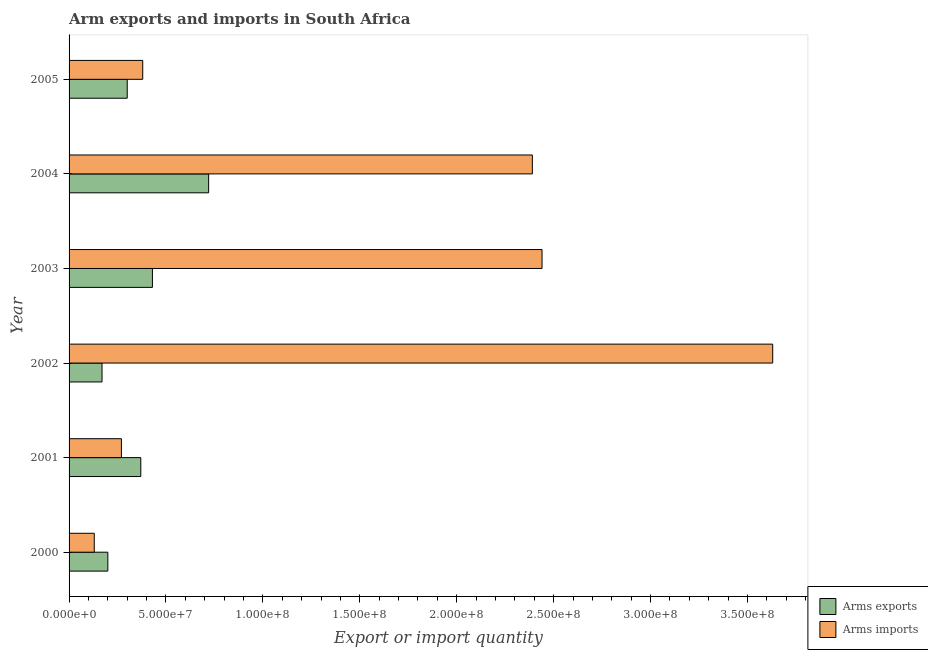How many different coloured bars are there?
Keep it short and to the point. 2. How many groups of bars are there?
Keep it short and to the point. 6. How many bars are there on the 4th tick from the top?
Provide a succinct answer. 2. How many bars are there on the 1st tick from the bottom?
Make the answer very short. 2. What is the label of the 3rd group of bars from the top?
Provide a succinct answer. 2003. In how many cases, is the number of bars for a given year not equal to the number of legend labels?
Ensure brevity in your answer.  0. What is the arms imports in 2003?
Ensure brevity in your answer.  2.44e+08. Across all years, what is the maximum arms exports?
Your answer should be very brief. 7.20e+07. Across all years, what is the minimum arms imports?
Offer a terse response. 1.30e+07. In which year was the arms imports maximum?
Your response must be concise. 2002. What is the total arms exports in the graph?
Offer a very short reply. 2.19e+08. What is the difference between the arms exports in 2001 and that in 2004?
Offer a terse response. -3.50e+07. What is the difference between the arms exports in 2002 and the arms imports in 2003?
Your response must be concise. -2.27e+08. What is the average arms exports per year?
Keep it short and to the point. 3.65e+07. In the year 2003, what is the difference between the arms exports and arms imports?
Your response must be concise. -2.01e+08. What is the ratio of the arms exports in 2000 to that in 2005?
Your answer should be very brief. 0.67. Is the arms exports in 2000 less than that in 2001?
Provide a succinct answer. Yes. What is the difference between the highest and the second highest arms imports?
Provide a succinct answer. 1.19e+08. What is the difference between the highest and the lowest arms imports?
Give a very brief answer. 3.50e+08. Is the sum of the arms exports in 2002 and 2005 greater than the maximum arms imports across all years?
Provide a short and direct response. No. What does the 2nd bar from the top in 2002 represents?
Your answer should be very brief. Arms exports. What does the 1st bar from the bottom in 2005 represents?
Your response must be concise. Arms exports. How many bars are there?
Your response must be concise. 12. Are all the bars in the graph horizontal?
Your answer should be very brief. Yes. Where does the legend appear in the graph?
Your answer should be very brief. Bottom right. What is the title of the graph?
Offer a terse response. Arm exports and imports in South Africa. Does "Fraud firms" appear as one of the legend labels in the graph?
Ensure brevity in your answer.  No. What is the label or title of the X-axis?
Offer a very short reply. Export or import quantity. What is the label or title of the Y-axis?
Your answer should be very brief. Year. What is the Export or import quantity of Arms exports in 2000?
Provide a short and direct response. 2.00e+07. What is the Export or import quantity in Arms imports in 2000?
Make the answer very short. 1.30e+07. What is the Export or import quantity of Arms exports in 2001?
Your response must be concise. 3.70e+07. What is the Export or import quantity of Arms imports in 2001?
Offer a terse response. 2.70e+07. What is the Export or import quantity of Arms exports in 2002?
Give a very brief answer. 1.70e+07. What is the Export or import quantity of Arms imports in 2002?
Provide a succinct answer. 3.63e+08. What is the Export or import quantity of Arms exports in 2003?
Make the answer very short. 4.30e+07. What is the Export or import quantity of Arms imports in 2003?
Give a very brief answer. 2.44e+08. What is the Export or import quantity in Arms exports in 2004?
Provide a short and direct response. 7.20e+07. What is the Export or import quantity in Arms imports in 2004?
Your answer should be compact. 2.39e+08. What is the Export or import quantity in Arms exports in 2005?
Your answer should be very brief. 3.00e+07. What is the Export or import quantity in Arms imports in 2005?
Provide a short and direct response. 3.80e+07. Across all years, what is the maximum Export or import quantity in Arms exports?
Your answer should be very brief. 7.20e+07. Across all years, what is the maximum Export or import quantity in Arms imports?
Your response must be concise. 3.63e+08. Across all years, what is the minimum Export or import quantity of Arms exports?
Make the answer very short. 1.70e+07. Across all years, what is the minimum Export or import quantity in Arms imports?
Your answer should be compact. 1.30e+07. What is the total Export or import quantity in Arms exports in the graph?
Ensure brevity in your answer.  2.19e+08. What is the total Export or import quantity of Arms imports in the graph?
Offer a very short reply. 9.24e+08. What is the difference between the Export or import quantity in Arms exports in 2000 and that in 2001?
Keep it short and to the point. -1.70e+07. What is the difference between the Export or import quantity of Arms imports in 2000 and that in 2001?
Your answer should be compact. -1.40e+07. What is the difference between the Export or import quantity of Arms imports in 2000 and that in 2002?
Your response must be concise. -3.50e+08. What is the difference between the Export or import quantity of Arms exports in 2000 and that in 2003?
Ensure brevity in your answer.  -2.30e+07. What is the difference between the Export or import quantity of Arms imports in 2000 and that in 2003?
Offer a terse response. -2.31e+08. What is the difference between the Export or import quantity of Arms exports in 2000 and that in 2004?
Your answer should be very brief. -5.20e+07. What is the difference between the Export or import quantity in Arms imports in 2000 and that in 2004?
Your answer should be very brief. -2.26e+08. What is the difference between the Export or import quantity of Arms exports in 2000 and that in 2005?
Provide a succinct answer. -1.00e+07. What is the difference between the Export or import quantity in Arms imports in 2000 and that in 2005?
Provide a succinct answer. -2.50e+07. What is the difference between the Export or import quantity of Arms exports in 2001 and that in 2002?
Your answer should be compact. 2.00e+07. What is the difference between the Export or import quantity in Arms imports in 2001 and that in 2002?
Ensure brevity in your answer.  -3.36e+08. What is the difference between the Export or import quantity of Arms exports in 2001 and that in 2003?
Offer a terse response. -6.00e+06. What is the difference between the Export or import quantity in Arms imports in 2001 and that in 2003?
Provide a short and direct response. -2.17e+08. What is the difference between the Export or import quantity in Arms exports in 2001 and that in 2004?
Your answer should be very brief. -3.50e+07. What is the difference between the Export or import quantity of Arms imports in 2001 and that in 2004?
Keep it short and to the point. -2.12e+08. What is the difference between the Export or import quantity of Arms imports in 2001 and that in 2005?
Your response must be concise. -1.10e+07. What is the difference between the Export or import quantity in Arms exports in 2002 and that in 2003?
Give a very brief answer. -2.60e+07. What is the difference between the Export or import quantity in Arms imports in 2002 and that in 2003?
Keep it short and to the point. 1.19e+08. What is the difference between the Export or import quantity of Arms exports in 2002 and that in 2004?
Make the answer very short. -5.50e+07. What is the difference between the Export or import quantity of Arms imports in 2002 and that in 2004?
Offer a very short reply. 1.24e+08. What is the difference between the Export or import quantity in Arms exports in 2002 and that in 2005?
Provide a succinct answer. -1.30e+07. What is the difference between the Export or import quantity in Arms imports in 2002 and that in 2005?
Offer a terse response. 3.25e+08. What is the difference between the Export or import quantity of Arms exports in 2003 and that in 2004?
Your answer should be compact. -2.90e+07. What is the difference between the Export or import quantity in Arms imports in 2003 and that in 2004?
Ensure brevity in your answer.  5.00e+06. What is the difference between the Export or import quantity of Arms exports in 2003 and that in 2005?
Your answer should be very brief. 1.30e+07. What is the difference between the Export or import quantity of Arms imports in 2003 and that in 2005?
Provide a succinct answer. 2.06e+08. What is the difference between the Export or import quantity in Arms exports in 2004 and that in 2005?
Your answer should be very brief. 4.20e+07. What is the difference between the Export or import quantity of Arms imports in 2004 and that in 2005?
Your answer should be compact. 2.01e+08. What is the difference between the Export or import quantity in Arms exports in 2000 and the Export or import quantity in Arms imports in 2001?
Your answer should be compact. -7.00e+06. What is the difference between the Export or import quantity of Arms exports in 2000 and the Export or import quantity of Arms imports in 2002?
Ensure brevity in your answer.  -3.43e+08. What is the difference between the Export or import quantity of Arms exports in 2000 and the Export or import quantity of Arms imports in 2003?
Make the answer very short. -2.24e+08. What is the difference between the Export or import quantity in Arms exports in 2000 and the Export or import quantity in Arms imports in 2004?
Make the answer very short. -2.19e+08. What is the difference between the Export or import quantity of Arms exports in 2000 and the Export or import quantity of Arms imports in 2005?
Make the answer very short. -1.80e+07. What is the difference between the Export or import quantity in Arms exports in 2001 and the Export or import quantity in Arms imports in 2002?
Your answer should be very brief. -3.26e+08. What is the difference between the Export or import quantity of Arms exports in 2001 and the Export or import quantity of Arms imports in 2003?
Give a very brief answer. -2.07e+08. What is the difference between the Export or import quantity of Arms exports in 2001 and the Export or import quantity of Arms imports in 2004?
Offer a very short reply. -2.02e+08. What is the difference between the Export or import quantity of Arms exports in 2002 and the Export or import quantity of Arms imports in 2003?
Your answer should be very brief. -2.27e+08. What is the difference between the Export or import quantity in Arms exports in 2002 and the Export or import quantity in Arms imports in 2004?
Provide a succinct answer. -2.22e+08. What is the difference between the Export or import quantity in Arms exports in 2002 and the Export or import quantity in Arms imports in 2005?
Offer a very short reply. -2.10e+07. What is the difference between the Export or import quantity of Arms exports in 2003 and the Export or import quantity of Arms imports in 2004?
Give a very brief answer. -1.96e+08. What is the difference between the Export or import quantity in Arms exports in 2004 and the Export or import quantity in Arms imports in 2005?
Your response must be concise. 3.40e+07. What is the average Export or import quantity in Arms exports per year?
Keep it short and to the point. 3.65e+07. What is the average Export or import quantity of Arms imports per year?
Make the answer very short. 1.54e+08. In the year 2000, what is the difference between the Export or import quantity of Arms exports and Export or import quantity of Arms imports?
Provide a short and direct response. 7.00e+06. In the year 2001, what is the difference between the Export or import quantity in Arms exports and Export or import quantity in Arms imports?
Your answer should be very brief. 1.00e+07. In the year 2002, what is the difference between the Export or import quantity of Arms exports and Export or import quantity of Arms imports?
Provide a succinct answer. -3.46e+08. In the year 2003, what is the difference between the Export or import quantity of Arms exports and Export or import quantity of Arms imports?
Your response must be concise. -2.01e+08. In the year 2004, what is the difference between the Export or import quantity in Arms exports and Export or import quantity in Arms imports?
Provide a short and direct response. -1.67e+08. In the year 2005, what is the difference between the Export or import quantity of Arms exports and Export or import quantity of Arms imports?
Ensure brevity in your answer.  -8.00e+06. What is the ratio of the Export or import quantity in Arms exports in 2000 to that in 2001?
Your answer should be very brief. 0.54. What is the ratio of the Export or import quantity in Arms imports in 2000 to that in 2001?
Provide a succinct answer. 0.48. What is the ratio of the Export or import quantity of Arms exports in 2000 to that in 2002?
Ensure brevity in your answer.  1.18. What is the ratio of the Export or import quantity of Arms imports in 2000 to that in 2002?
Provide a short and direct response. 0.04. What is the ratio of the Export or import quantity in Arms exports in 2000 to that in 2003?
Ensure brevity in your answer.  0.47. What is the ratio of the Export or import quantity in Arms imports in 2000 to that in 2003?
Make the answer very short. 0.05. What is the ratio of the Export or import quantity of Arms exports in 2000 to that in 2004?
Ensure brevity in your answer.  0.28. What is the ratio of the Export or import quantity in Arms imports in 2000 to that in 2004?
Offer a very short reply. 0.05. What is the ratio of the Export or import quantity in Arms exports in 2000 to that in 2005?
Offer a very short reply. 0.67. What is the ratio of the Export or import quantity in Arms imports in 2000 to that in 2005?
Your answer should be compact. 0.34. What is the ratio of the Export or import quantity of Arms exports in 2001 to that in 2002?
Make the answer very short. 2.18. What is the ratio of the Export or import quantity of Arms imports in 2001 to that in 2002?
Your answer should be compact. 0.07. What is the ratio of the Export or import quantity in Arms exports in 2001 to that in 2003?
Offer a terse response. 0.86. What is the ratio of the Export or import quantity of Arms imports in 2001 to that in 2003?
Ensure brevity in your answer.  0.11. What is the ratio of the Export or import quantity of Arms exports in 2001 to that in 2004?
Your answer should be compact. 0.51. What is the ratio of the Export or import quantity in Arms imports in 2001 to that in 2004?
Offer a terse response. 0.11. What is the ratio of the Export or import quantity in Arms exports in 2001 to that in 2005?
Provide a succinct answer. 1.23. What is the ratio of the Export or import quantity of Arms imports in 2001 to that in 2005?
Your answer should be compact. 0.71. What is the ratio of the Export or import quantity in Arms exports in 2002 to that in 2003?
Provide a succinct answer. 0.4. What is the ratio of the Export or import quantity in Arms imports in 2002 to that in 2003?
Ensure brevity in your answer.  1.49. What is the ratio of the Export or import quantity in Arms exports in 2002 to that in 2004?
Make the answer very short. 0.24. What is the ratio of the Export or import quantity in Arms imports in 2002 to that in 2004?
Keep it short and to the point. 1.52. What is the ratio of the Export or import quantity in Arms exports in 2002 to that in 2005?
Ensure brevity in your answer.  0.57. What is the ratio of the Export or import quantity in Arms imports in 2002 to that in 2005?
Your answer should be very brief. 9.55. What is the ratio of the Export or import quantity of Arms exports in 2003 to that in 2004?
Provide a succinct answer. 0.6. What is the ratio of the Export or import quantity in Arms imports in 2003 to that in 2004?
Ensure brevity in your answer.  1.02. What is the ratio of the Export or import quantity of Arms exports in 2003 to that in 2005?
Your answer should be very brief. 1.43. What is the ratio of the Export or import quantity of Arms imports in 2003 to that in 2005?
Your response must be concise. 6.42. What is the ratio of the Export or import quantity in Arms exports in 2004 to that in 2005?
Provide a succinct answer. 2.4. What is the ratio of the Export or import quantity in Arms imports in 2004 to that in 2005?
Make the answer very short. 6.29. What is the difference between the highest and the second highest Export or import quantity of Arms exports?
Your answer should be very brief. 2.90e+07. What is the difference between the highest and the second highest Export or import quantity of Arms imports?
Offer a very short reply. 1.19e+08. What is the difference between the highest and the lowest Export or import quantity of Arms exports?
Your response must be concise. 5.50e+07. What is the difference between the highest and the lowest Export or import quantity of Arms imports?
Ensure brevity in your answer.  3.50e+08. 